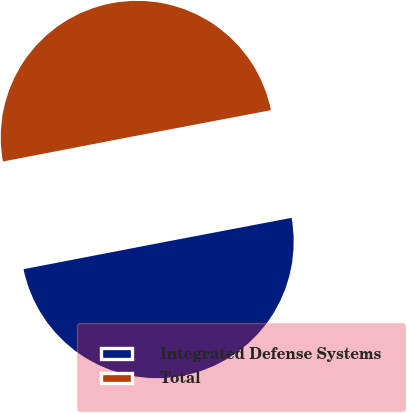Convert chart to OTSL. <chart><loc_0><loc_0><loc_500><loc_500><pie_chart><fcel>Integrated Defense Systems<fcel>Total<nl><fcel>49.96%<fcel>50.04%<nl></chart> 